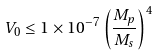<formula> <loc_0><loc_0><loc_500><loc_500>V _ { 0 } \leq 1 \times 1 0 ^ { - 7 } \left ( \frac { M _ { p } } { M _ { s } } \right ) ^ { 4 }</formula> 